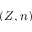<formula> <loc_0><loc_0><loc_500><loc_500>( Z , n )</formula> 